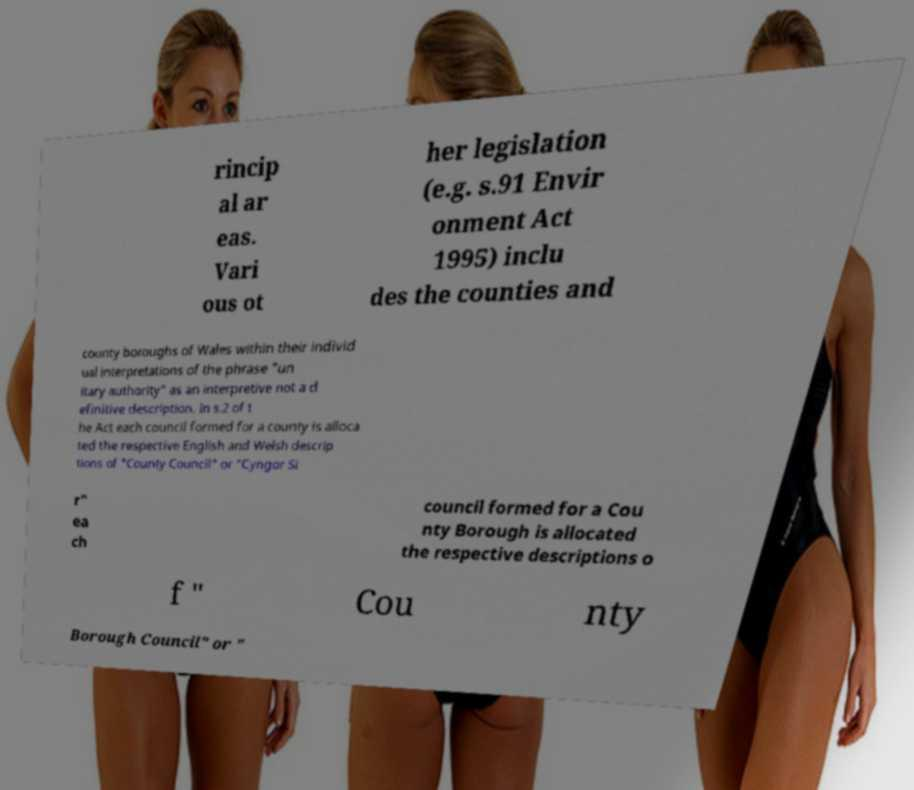For documentation purposes, I need the text within this image transcribed. Could you provide that? rincip al ar eas. Vari ous ot her legislation (e.g. s.91 Envir onment Act 1995) inclu des the counties and county boroughs of Wales within their individ ual interpretations of the phrase "un itary authority" as an interpretive not a d efinitive description. In s.2 of t he Act each council formed for a county is alloca ted the respective English and Welsh descrip tions of "County Council" or "Cyngor Si r" ea ch council formed for a Cou nty Borough is allocated the respective descriptions o f " Cou nty Borough Council" or " 